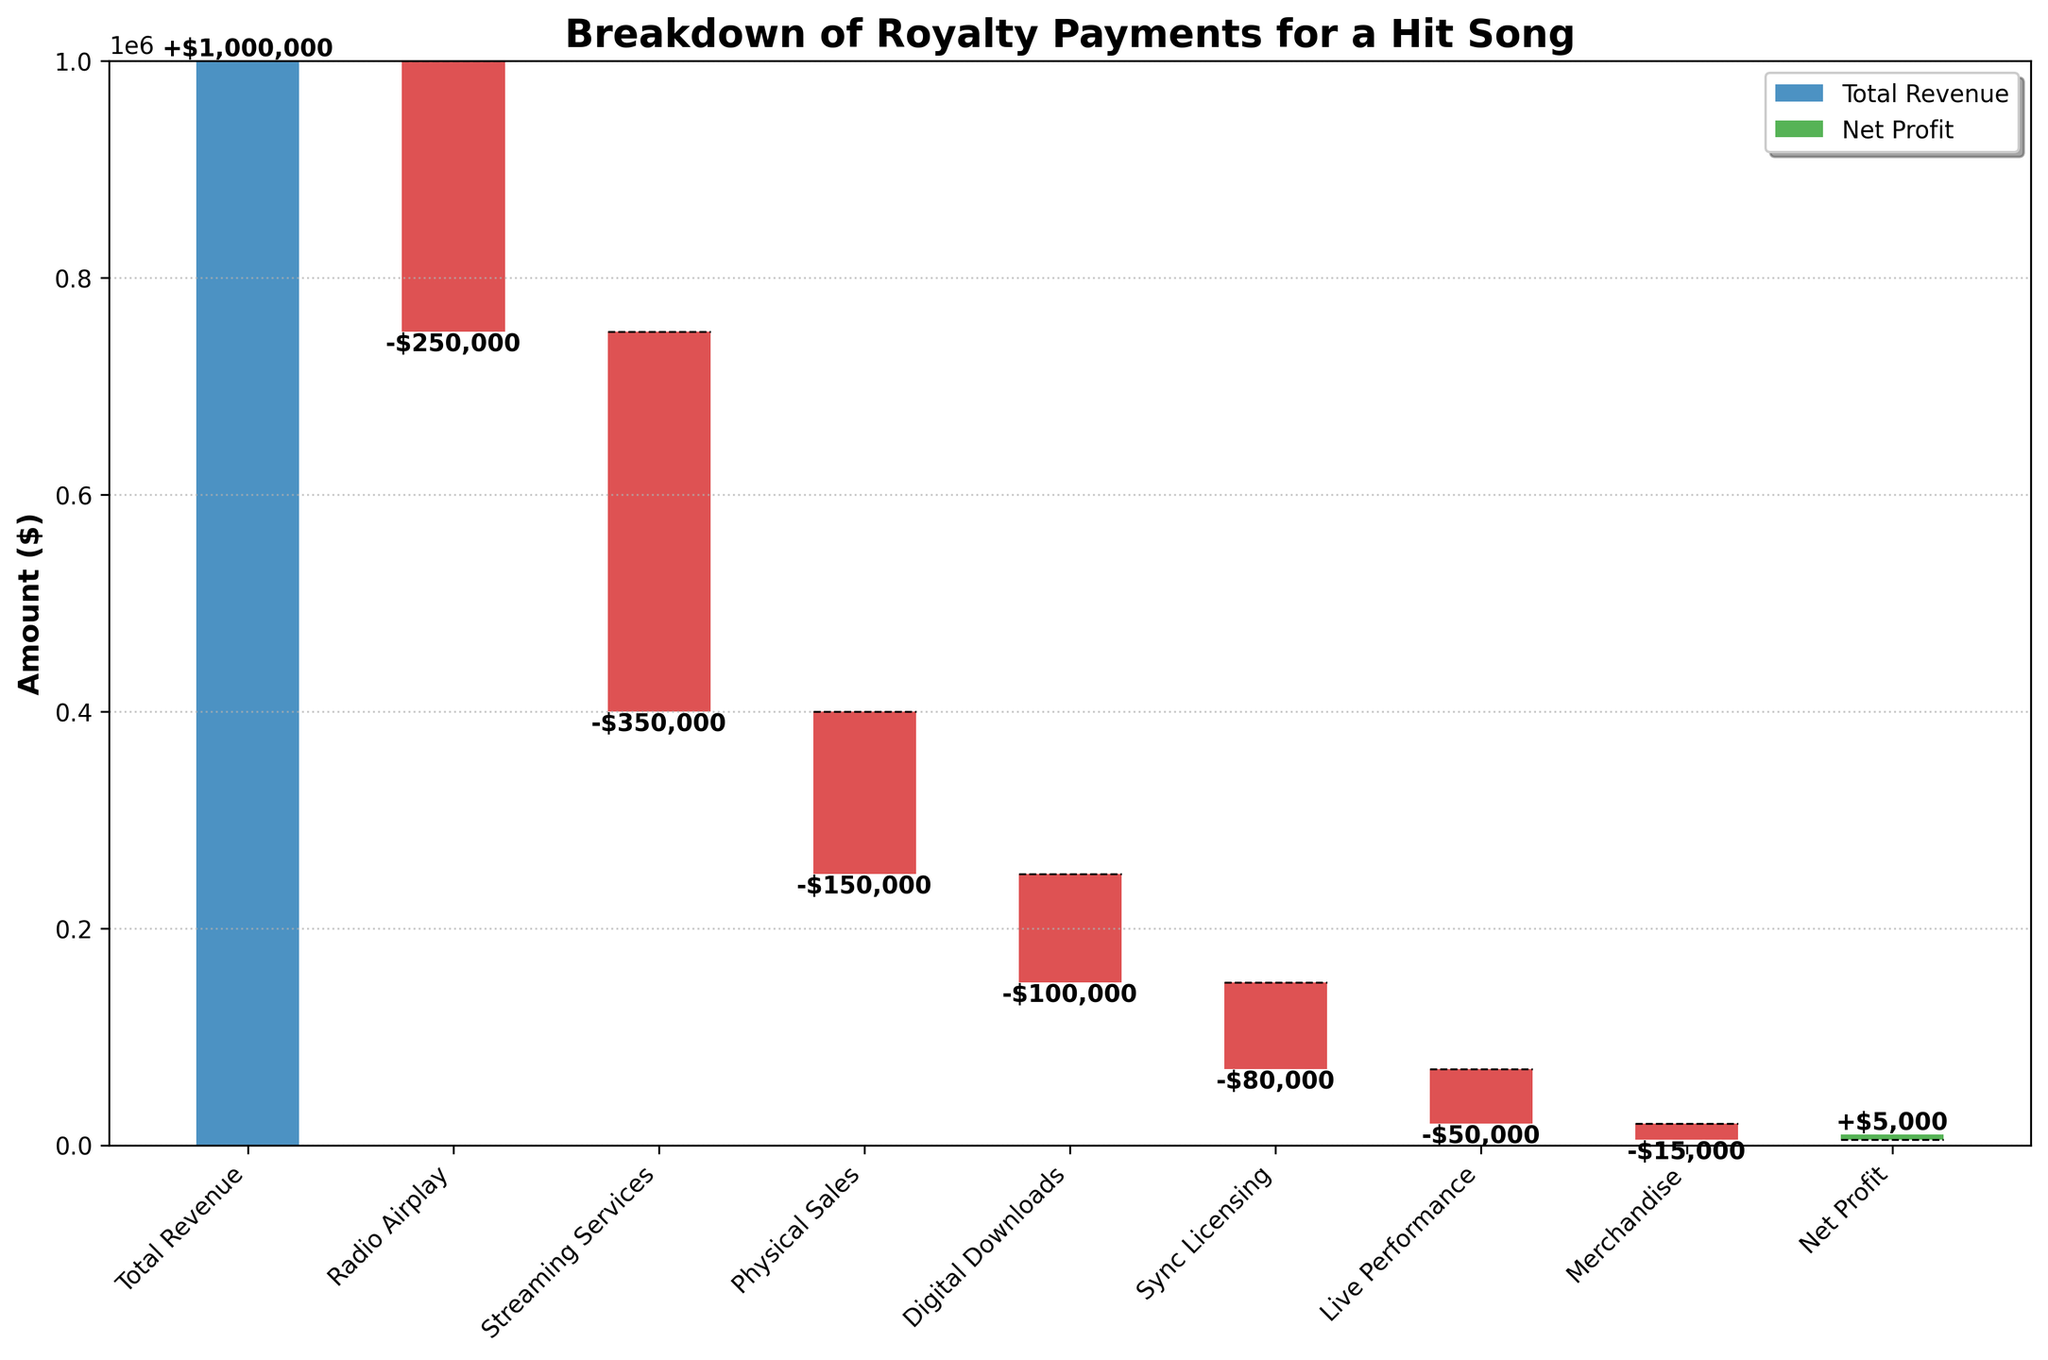What is the title of the chart? The title is usually located at the top of the chart in larger or bold font. In this chart, the title is "Breakdown of Royalty Payments for a Hit Song."
Answer: Breakdown of Royalty Payments for a Hit Song How much is the Total Revenue? The Total Revenue is represented by the first bar in the chart, which is labeled and shows a value of $1,000,000.
Answer: $1,000,000 What category contributes the most to the deductions from the Total Revenue? By examining the lengths of the negative bars, the Streaming Services category has the largest deduction value. The chart shows that Streaming Services deducts $350,000.
Answer: Streaming Services What is the amount deducted by Radio Airplay? The Radio Airplay category has a negative bar that shows the deduction amount. This value is -$250,000.
Answer: $250,000 Which categories deduct less than $100,000 each from Total Revenue? By examining the negative bars, Digital Downloads, Sync Licensing, Live Performance, and Merchandise fall under $100,000 in deductions. Their values are -$100,000, -$80,000, -$50,000, and -$15,000 respectively.
Answer: Digital Downloads, Sync Licensing, Live Performance, Merchandise What is the final Net Profit? The Net Profit is represented by the last bar in the chart, which is labeled and shows a value of $5,000.
Answer: $5,000 What is the cumulative sum after the Physical Sales deduction? Adding Total Revenue first ($1,000,000), then deducting Radio Airplay ($250,000), and Streaming Services ($350,000), then Physical Sales ($150,000) leads to $250,000.
Answer: $250,000 What is the ratio of the Streaming Services deductions to Radio Airplay deductions? To compute the ratio, use the formula (Streaming Services deduction / Radio Airplay deduction), which means $350,000 / $250,000 = 1.4.
Answer: 1.4 Compare the deductions of Physical Sales and Live Performances, which is higher? By examining the values, Physical Sales deduct $150,000, and Live Performance deducts $50,000. Therefore, Physical Sales have a higher deduction.
Answer: Physical Sales How do Merchandise and Live Performance deductions compare? Merchandise deductions amount to $15,000 while Live Performance deductions amount to $50,000. Live Performance deductions are therefore greater.
Answer: Live Performance What are the cumulative deductions before reaching Sync Licensing? Adding up all deductions before Sync Licensing means calculating $250,000 (Radio Airplay) + $350,000 (Streaming Services) + $150,000 (Physical Sales) + $100,000 (Digital Downloads), which totals $850,000.
Answer: $850,000 